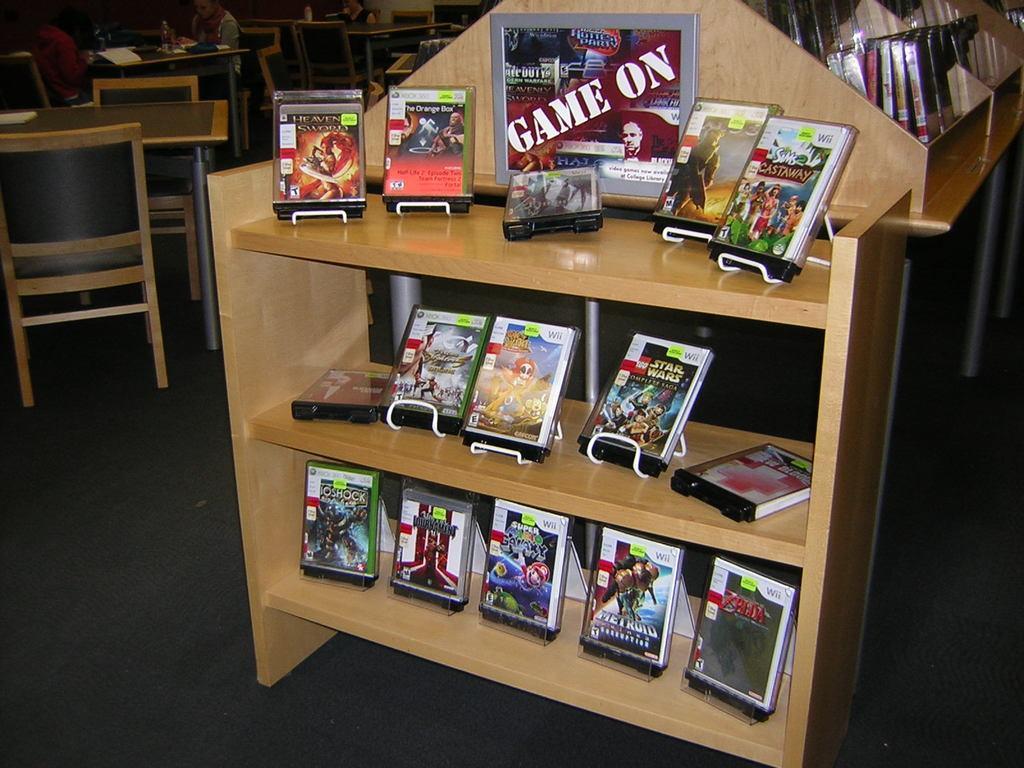In one or two sentences, can you explain what this image depicts? In this image we can see a board with some text and some CD cases which are placed in the racks. We can also see some people sitting on the chairs and a table containing some objects on it. We can also see some empty chairs and the tables. 